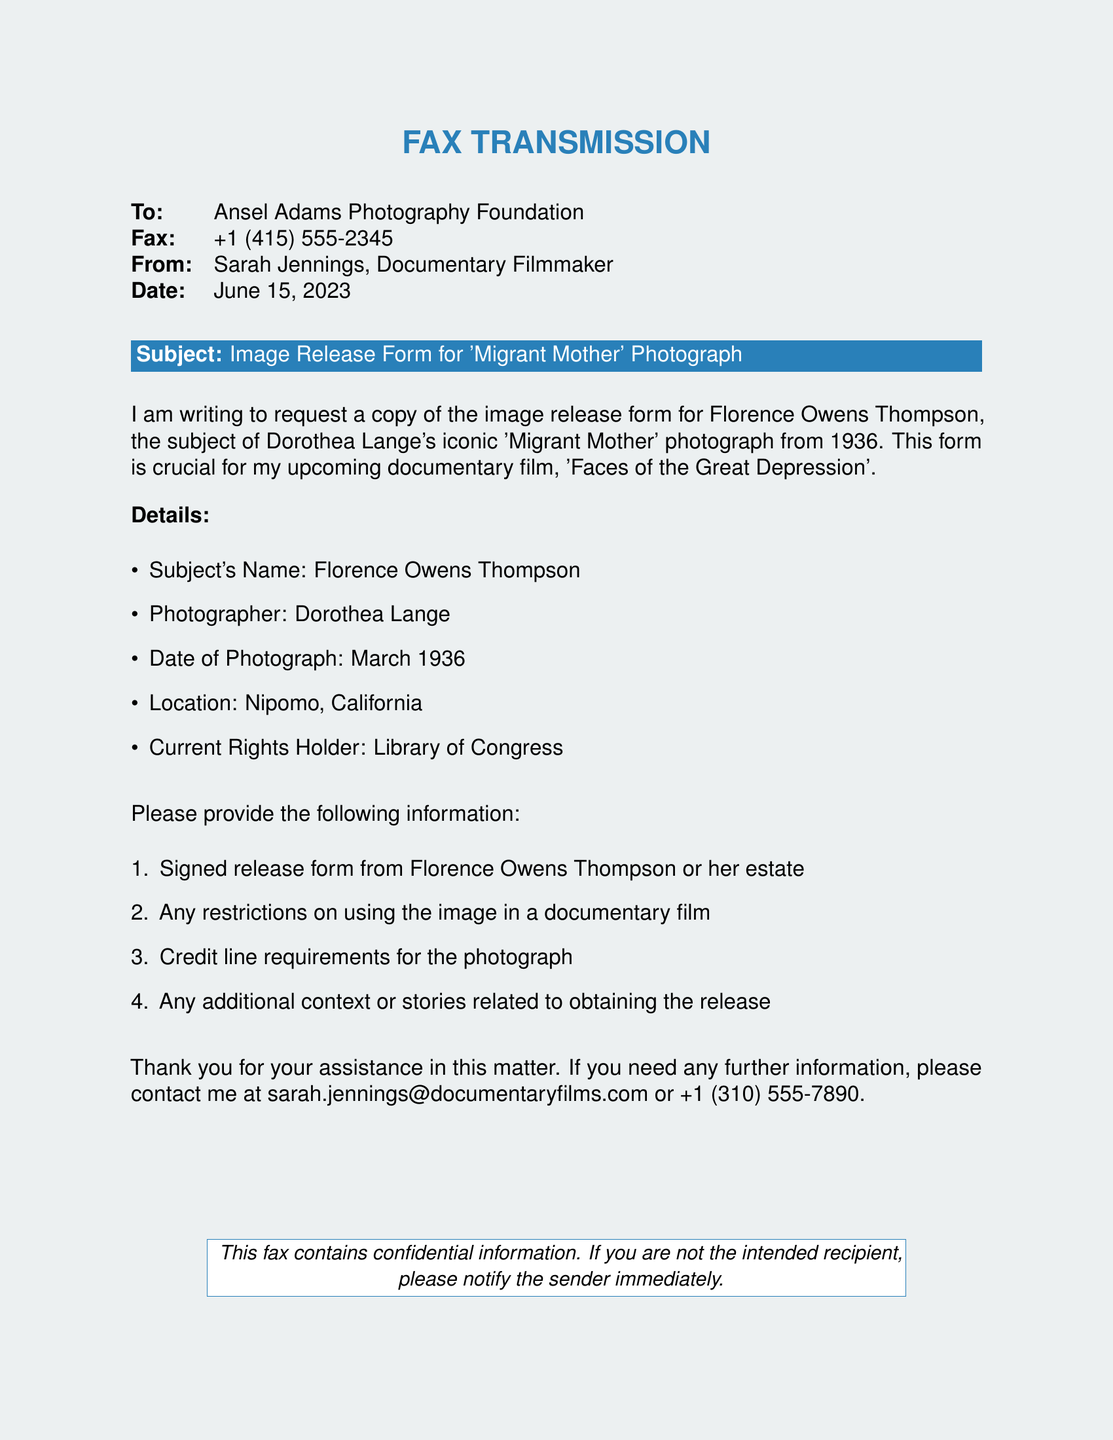What is the subject's name? The subject's name is explicitly mentioned in the details section of the document.
Answer: Florence Owens Thompson Who is the photographer of the iconic photograph? The photographer is stated clearly in the document.
Answer: Dorothea Lange What date was the photograph taken? The date can be found in the details section of the document.
Answer: March 1936 What is the purpose of the fax? The purpose is indicated in the opening lines of the document, requesting information.
Answer: Request a copy of the image release form What is the sender's email address? The sender's contact information is provided at the end of the document.
Answer: sarah.jennings@documentaryfilms.com What is the title of the documentary film? The title is included in the introduction of the document regarding the film project.
Answer: Faces of the Great Depression What are the restrictions the sender is inquiring about? The sender asks about restrictions related to the use of the image in a documentary film.
Answer: Restrictions on using the image What is the current rights holder mentioned in the document? The current rights holder is specified in the details section of the document.
Answer: Library of Congress What is the fax date? The date is included at the top of the document.
Answer: June 15, 2023 